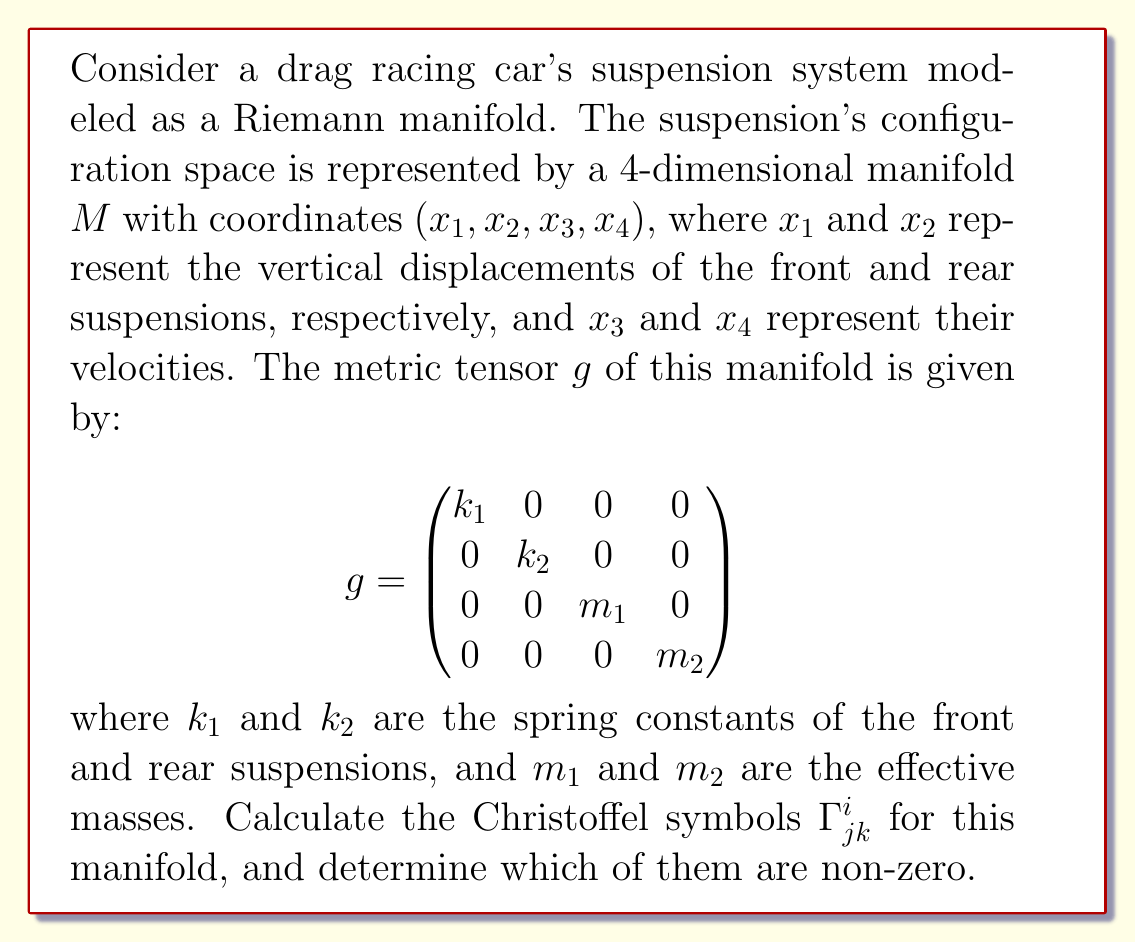Show me your answer to this math problem. To solve this problem, we need to follow these steps:

1) Recall the formula for Christoffel symbols in terms of the metric tensor:

   $$\Gamma^i_{jk} = \frac{1}{2}g^{im}\left(\frac{\partial g_{mj}}{\partial x^k} + \frac{\partial g_{mk}}{\partial x^j} - \frac{\partial g_{jk}}{\partial x^m}\right)$$

2) First, we need to find the inverse of the metric tensor $g^{-1}$:

   $$g^{-1} = \begin{pmatrix}
   1/k_1 & 0 & 0 & 0 \\
   0 & 1/k_2 & 0 & 0 \\
   0 & 0 & 1/m_1 & 0 \\
   0 & 0 & 0 & 1/m_2
   \end{pmatrix}$$

3) Now, we need to calculate the partial derivatives of the metric tensor components. However, we can see that all components of $g$ are constants, so all partial derivatives are zero:

   $$\frac{\partial g_{mj}}{\partial x^k} = 0 \quad \text{for all } m,j,k$$

4) Substituting this into the Christoffel symbol formula:

   $$\Gamma^i_{jk} = \frac{1}{2}g^{im}(0 + 0 - 0) = 0$$

5) This result holds for all values of $i$, $j$, and $k$. Therefore, all Christoffel symbols are zero for this manifold.

This result is consistent with the physical interpretation of the suspension system. The Christoffel symbols represent the "curvature" of the manifold, and in this case, the manifold is flat (Euclidean), which corresponds to a linear suspension system without coupling between the front and rear suspensions.
Answer: All Christoffel symbols $\Gamma^i_{jk}$ are zero for this manifold. 